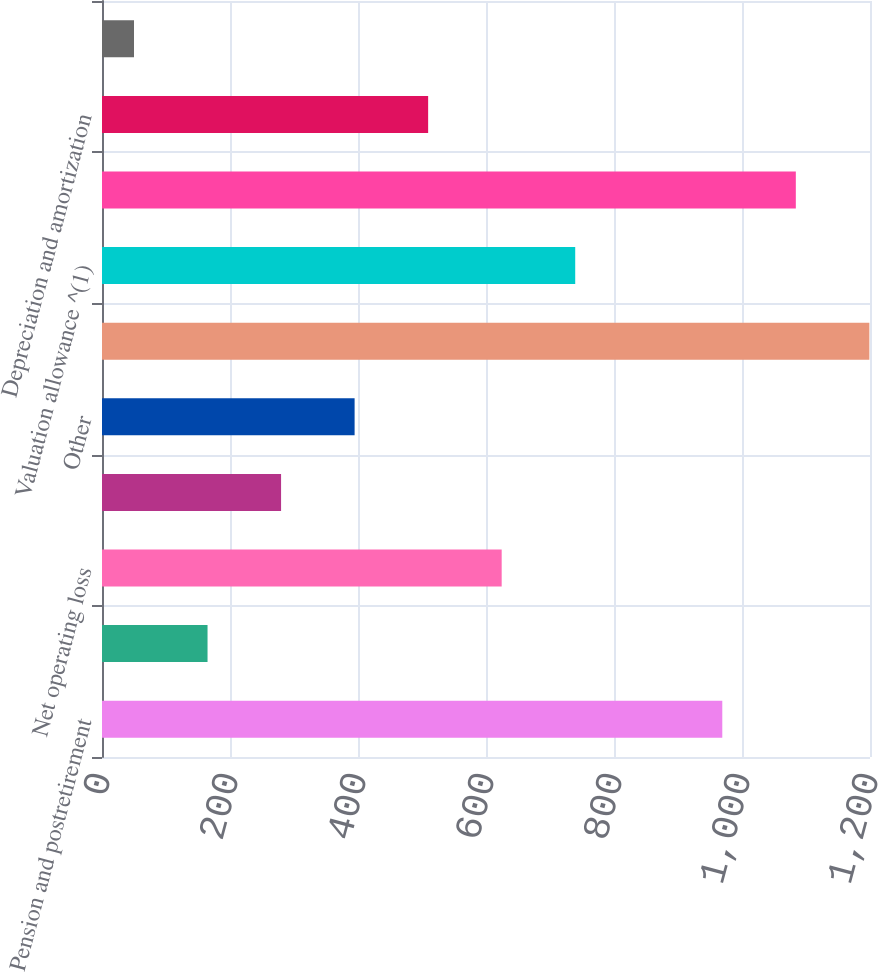Convert chart. <chart><loc_0><loc_0><loc_500><loc_500><bar_chart><fcel>Pension and postretirement<fcel>Accrued expenses<fcel>Net operating loss<fcel>Tax credit carryforwards<fcel>Other<fcel>Subtotal<fcel>Valuation allowance ^(1)<fcel>Total<fcel>Depreciation and amortization<fcel>Investments in affiliates<nl><fcel>969.2<fcel>164.9<fcel>624.5<fcel>279.8<fcel>394.7<fcel>1199<fcel>739.4<fcel>1084.1<fcel>509.6<fcel>50<nl></chart> 